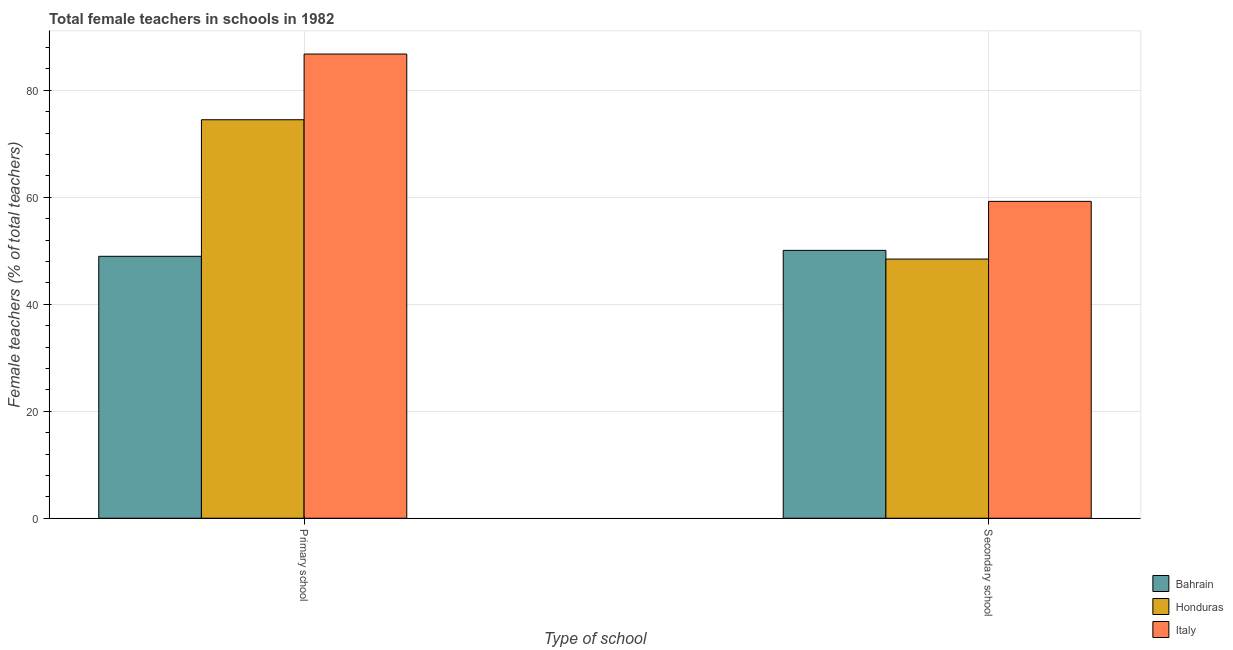How many bars are there on the 1st tick from the left?
Keep it short and to the point. 3. How many bars are there on the 2nd tick from the right?
Keep it short and to the point. 3. What is the label of the 1st group of bars from the left?
Keep it short and to the point. Primary school. What is the percentage of female teachers in secondary schools in Honduras?
Provide a short and direct response. 48.44. Across all countries, what is the maximum percentage of female teachers in primary schools?
Make the answer very short. 86.77. Across all countries, what is the minimum percentage of female teachers in primary schools?
Your response must be concise. 48.96. In which country was the percentage of female teachers in secondary schools maximum?
Provide a succinct answer. Italy. In which country was the percentage of female teachers in secondary schools minimum?
Offer a terse response. Honduras. What is the total percentage of female teachers in secondary schools in the graph?
Keep it short and to the point. 157.74. What is the difference between the percentage of female teachers in secondary schools in Italy and that in Bahrain?
Make the answer very short. 9.16. What is the difference between the percentage of female teachers in primary schools in Italy and the percentage of female teachers in secondary schools in Bahrain?
Your answer should be very brief. 36.7. What is the average percentage of female teachers in secondary schools per country?
Keep it short and to the point. 52.58. What is the difference between the percentage of female teachers in primary schools and percentage of female teachers in secondary schools in Italy?
Offer a terse response. 27.54. In how many countries, is the percentage of female teachers in secondary schools greater than 72 %?
Offer a terse response. 0. What is the ratio of the percentage of female teachers in primary schools in Bahrain to that in Italy?
Your response must be concise. 0.56. Is the percentage of female teachers in primary schools in Honduras less than that in Italy?
Make the answer very short. Yes. What does the 2nd bar from the left in Secondary school represents?
Your response must be concise. Honduras. What does the 2nd bar from the right in Secondary school represents?
Provide a succinct answer. Honduras. What is the difference between two consecutive major ticks on the Y-axis?
Your answer should be compact. 20. Are the values on the major ticks of Y-axis written in scientific E-notation?
Offer a terse response. No. Does the graph contain any zero values?
Your answer should be very brief. No. Does the graph contain grids?
Your response must be concise. Yes. How are the legend labels stacked?
Give a very brief answer. Vertical. What is the title of the graph?
Ensure brevity in your answer.  Total female teachers in schools in 1982. What is the label or title of the X-axis?
Your answer should be very brief. Type of school. What is the label or title of the Y-axis?
Make the answer very short. Female teachers (% of total teachers). What is the Female teachers (% of total teachers) of Bahrain in Primary school?
Provide a short and direct response. 48.96. What is the Female teachers (% of total teachers) of Honduras in Primary school?
Make the answer very short. 74.48. What is the Female teachers (% of total teachers) of Italy in Primary school?
Provide a succinct answer. 86.77. What is the Female teachers (% of total teachers) in Bahrain in Secondary school?
Make the answer very short. 50.07. What is the Female teachers (% of total teachers) of Honduras in Secondary school?
Your answer should be very brief. 48.44. What is the Female teachers (% of total teachers) of Italy in Secondary school?
Make the answer very short. 59.23. Across all Type of school, what is the maximum Female teachers (% of total teachers) of Bahrain?
Give a very brief answer. 50.07. Across all Type of school, what is the maximum Female teachers (% of total teachers) in Honduras?
Your answer should be very brief. 74.48. Across all Type of school, what is the maximum Female teachers (% of total teachers) in Italy?
Make the answer very short. 86.77. Across all Type of school, what is the minimum Female teachers (% of total teachers) in Bahrain?
Provide a short and direct response. 48.96. Across all Type of school, what is the minimum Female teachers (% of total teachers) in Honduras?
Your answer should be very brief. 48.44. Across all Type of school, what is the minimum Female teachers (% of total teachers) of Italy?
Provide a succinct answer. 59.23. What is the total Female teachers (% of total teachers) of Bahrain in the graph?
Keep it short and to the point. 99.03. What is the total Female teachers (% of total teachers) in Honduras in the graph?
Give a very brief answer. 122.92. What is the total Female teachers (% of total teachers) in Italy in the graph?
Your answer should be very brief. 146. What is the difference between the Female teachers (% of total teachers) of Bahrain in Primary school and that in Secondary school?
Your answer should be very brief. -1.11. What is the difference between the Female teachers (% of total teachers) in Honduras in Primary school and that in Secondary school?
Offer a terse response. 26.04. What is the difference between the Female teachers (% of total teachers) in Italy in Primary school and that in Secondary school?
Provide a succinct answer. 27.54. What is the difference between the Female teachers (% of total teachers) of Bahrain in Primary school and the Female teachers (% of total teachers) of Honduras in Secondary school?
Ensure brevity in your answer.  0.52. What is the difference between the Female teachers (% of total teachers) of Bahrain in Primary school and the Female teachers (% of total teachers) of Italy in Secondary school?
Make the answer very short. -10.27. What is the difference between the Female teachers (% of total teachers) of Honduras in Primary school and the Female teachers (% of total teachers) of Italy in Secondary school?
Your answer should be compact. 15.26. What is the average Female teachers (% of total teachers) of Bahrain per Type of school?
Offer a very short reply. 49.51. What is the average Female teachers (% of total teachers) in Honduras per Type of school?
Your answer should be compact. 61.46. What is the average Female teachers (% of total teachers) of Italy per Type of school?
Your answer should be compact. 73. What is the difference between the Female teachers (% of total teachers) of Bahrain and Female teachers (% of total teachers) of Honduras in Primary school?
Provide a succinct answer. -25.53. What is the difference between the Female teachers (% of total teachers) in Bahrain and Female teachers (% of total teachers) in Italy in Primary school?
Your answer should be compact. -37.81. What is the difference between the Female teachers (% of total teachers) of Honduras and Female teachers (% of total teachers) of Italy in Primary school?
Make the answer very short. -12.28. What is the difference between the Female teachers (% of total teachers) in Bahrain and Female teachers (% of total teachers) in Honduras in Secondary school?
Your answer should be compact. 1.63. What is the difference between the Female teachers (% of total teachers) of Bahrain and Female teachers (% of total teachers) of Italy in Secondary school?
Ensure brevity in your answer.  -9.16. What is the difference between the Female teachers (% of total teachers) in Honduras and Female teachers (% of total teachers) in Italy in Secondary school?
Your answer should be compact. -10.79. What is the ratio of the Female teachers (% of total teachers) of Bahrain in Primary school to that in Secondary school?
Offer a terse response. 0.98. What is the ratio of the Female teachers (% of total teachers) in Honduras in Primary school to that in Secondary school?
Give a very brief answer. 1.54. What is the ratio of the Female teachers (% of total teachers) of Italy in Primary school to that in Secondary school?
Give a very brief answer. 1.46. What is the difference between the highest and the second highest Female teachers (% of total teachers) of Bahrain?
Offer a very short reply. 1.11. What is the difference between the highest and the second highest Female teachers (% of total teachers) in Honduras?
Your answer should be compact. 26.04. What is the difference between the highest and the second highest Female teachers (% of total teachers) in Italy?
Provide a succinct answer. 27.54. What is the difference between the highest and the lowest Female teachers (% of total teachers) of Bahrain?
Ensure brevity in your answer.  1.11. What is the difference between the highest and the lowest Female teachers (% of total teachers) in Honduras?
Your answer should be very brief. 26.04. What is the difference between the highest and the lowest Female teachers (% of total teachers) in Italy?
Your response must be concise. 27.54. 